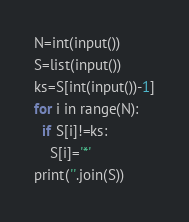Convert code to text. <code><loc_0><loc_0><loc_500><loc_500><_Python_>N=int(input())
S=list(input())
ks=S[int(input())-1]
for i in range(N):
  if S[i]!=ks:
    S[i]='*'
print(''.join(S))</code> 